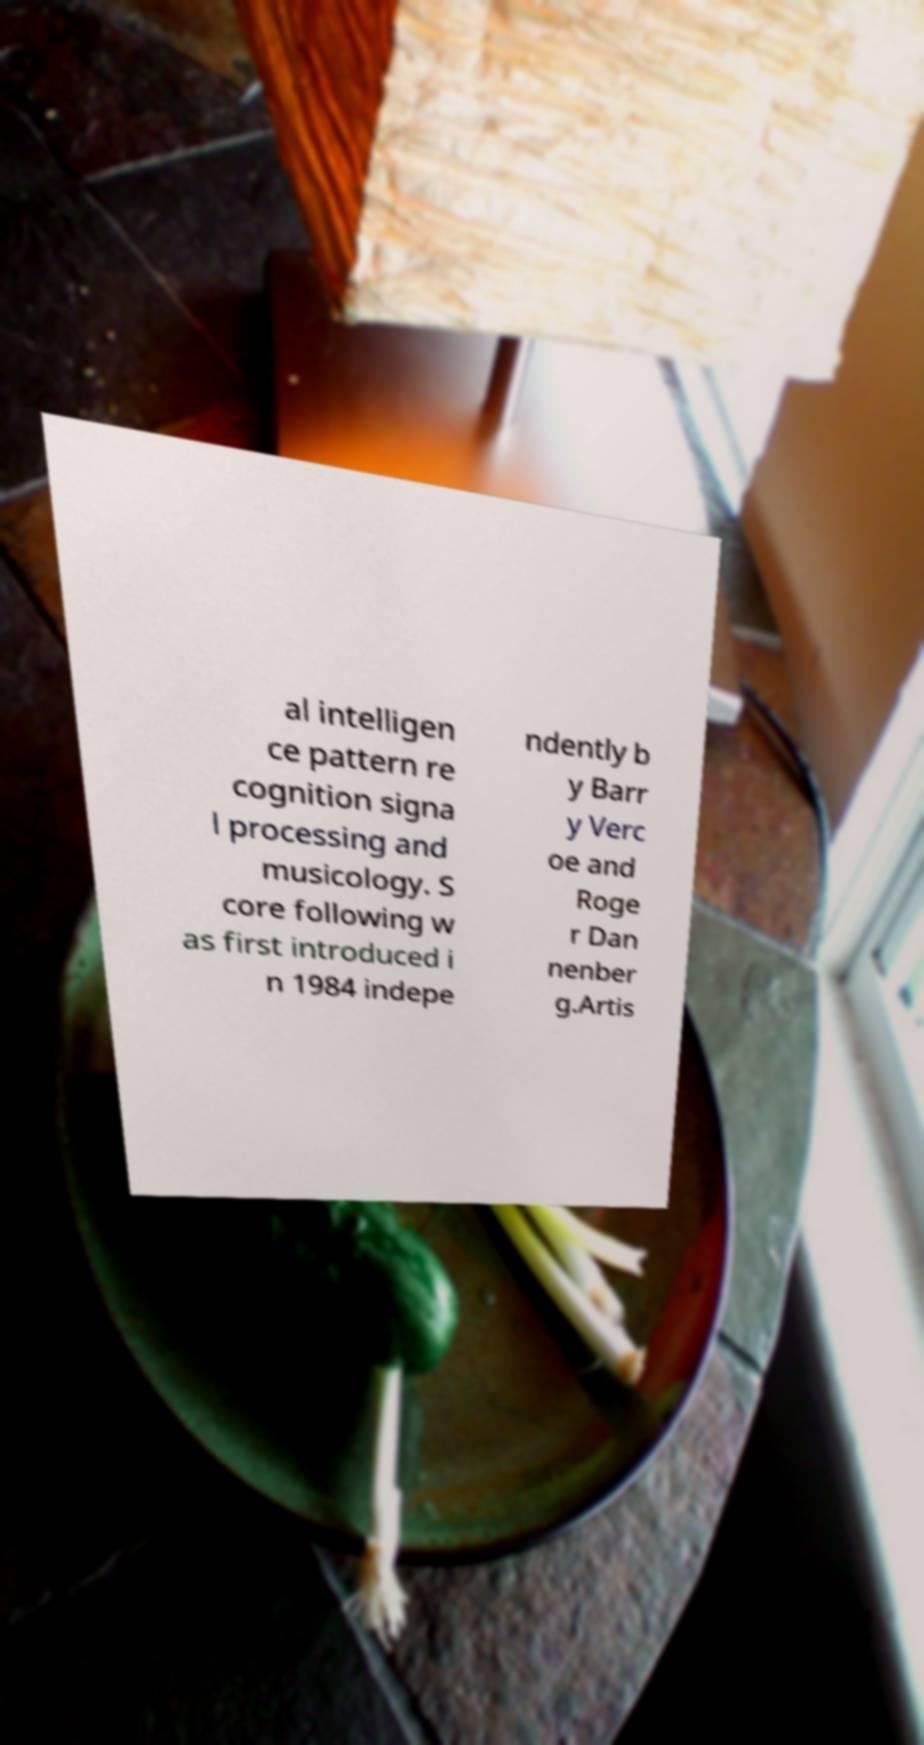I need the written content from this picture converted into text. Can you do that? al intelligen ce pattern re cognition signa l processing and musicology. S core following w as first introduced i n 1984 indepe ndently b y Barr y Verc oe and Roge r Dan nenber g.Artis 